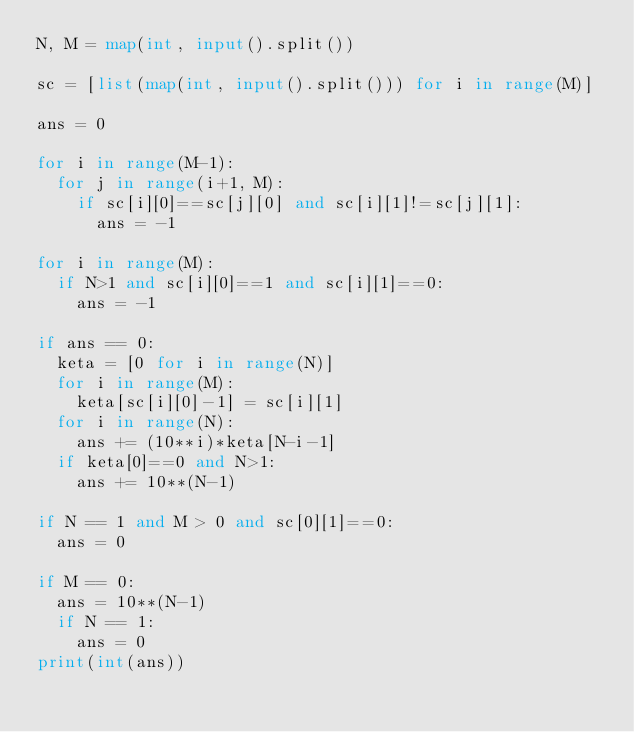<code> <loc_0><loc_0><loc_500><loc_500><_Python_>N, M = map(int, input().split())

sc = [list(map(int, input().split())) for i in range(M)]

ans = 0

for i in range(M-1):
  for j in range(i+1, M):
    if sc[i][0]==sc[j][0] and sc[i][1]!=sc[j][1]:
      ans = -1

for i in range(M):
  if N>1 and sc[i][0]==1 and sc[i][1]==0:
    ans = -1

if ans == 0:
  keta = [0 for i in range(N)]
  for i in range(M):
    keta[sc[i][0]-1] = sc[i][1]
  for i in range(N):
    ans += (10**i)*keta[N-i-1]
  if keta[0]==0 and N>1:
    ans += 10**(N-1)

if N == 1 and M > 0 and sc[0][1]==0:
  ans = 0

if M == 0:
  ans = 10**(N-1)
  if N == 1:
    ans = 0
print(int(ans))</code> 